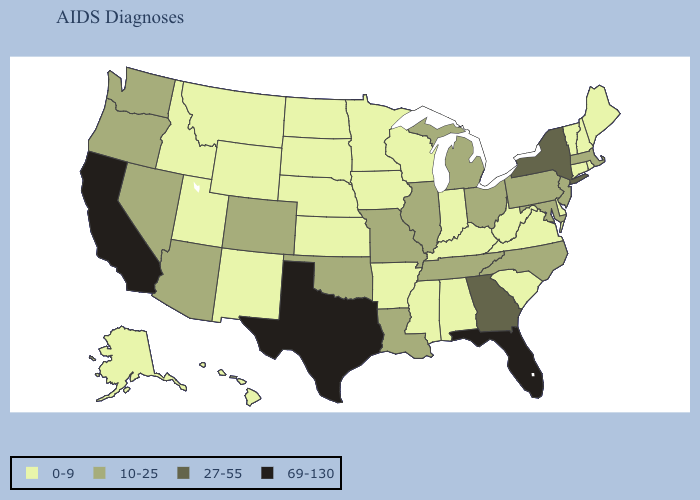Which states have the lowest value in the USA?
Answer briefly. Alabama, Alaska, Arkansas, Connecticut, Delaware, Hawaii, Idaho, Indiana, Iowa, Kansas, Kentucky, Maine, Minnesota, Mississippi, Montana, Nebraska, New Hampshire, New Mexico, North Dakota, Rhode Island, South Carolina, South Dakota, Utah, Vermont, Virginia, West Virginia, Wisconsin, Wyoming. Among the states that border Vermont , does New Hampshire have the highest value?
Quick response, please. No. What is the lowest value in the USA?
Short answer required. 0-9. Name the states that have a value in the range 0-9?
Be succinct. Alabama, Alaska, Arkansas, Connecticut, Delaware, Hawaii, Idaho, Indiana, Iowa, Kansas, Kentucky, Maine, Minnesota, Mississippi, Montana, Nebraska, New Hampshire, New Mexico, North Dakota, Rhode Island, South Carolina, South Dakota, Utah, Vermont, Virginia, West Virginia, Wisconsin, Wyoming. What is the highest value in the West ?
Concise answer only. 69-130. Name the states that have a value in the range 10-25?
Answer briefly. Arizona, Colorado, Illinois, Louisiana, Maryland, Massachusetts, Michigan, Missouri, Nevada, New Jersey, North Carolina, Ohio, Oklahoma, Oregon, Pennsylvania, Tennessee, Washington. Does Mississippi have the highest value in the USA?
Quick response, please. No. Name the states that have a value in the range 0-9?
Keep it brief. Alabama, Alaska, Arkansas, Connecticut, Delaware, Hawaii, Idaho, Indiana, Iowa, Kansas, Kentucky, Maine, Minnesota, Mississippi, Montana, Nebraska, New Hampshire, New Mexico, North Dakota, Rhode Island, South Carolina, South Dakota, Utah, Vermont, Virginia, West Virginia, Wisconsin, Wyoming. Does Texas have a lower value than North Carolina?
Give a very brief answer. No. Does the map have missing data?
Keep it brief. No. What is the value of Minnesota?
Answer briefly. 0-9. What is the value of New Jersey?
Write a very short answer. 10-25. Which states have the lowest value in the USA?
Give a very brief answer. Alabama, Alaska, Arkansas, Connecticut, Delaware, Hawaii, Idaho, Indiana, Iowa, Kansas, Kentucky, Maine, Minnesota, Mississippi, Montana, Nebraska, New Hampshire, New Mexico, North Dakota, Rhode Island, South Carolina, South Dakota, Utah, Vermont, Virginia, West Virginia, Wisconsin, Wyoming. What is the value of Massachusetts?
Answer briefly. 10-25. What is the lowest value in the Northeast?
Quick response, please. 0-9. 